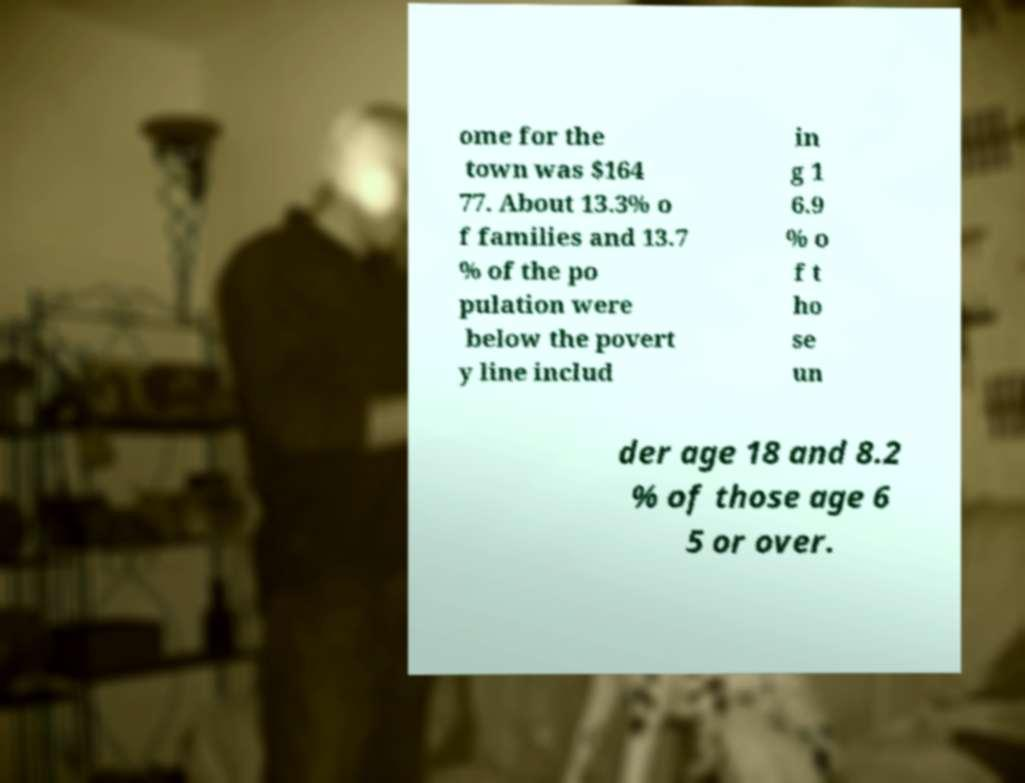There's text embedded in this image that I need extracted. Can you transcribe it verbatim? ome for the town was $164 77. About 13.3% o f families and 13.7 % of the po pulation were below the povert y line includ in g 1 6.9 % o f t ho se un der age 18 and 8.2 % of those age 6 5 or over. 